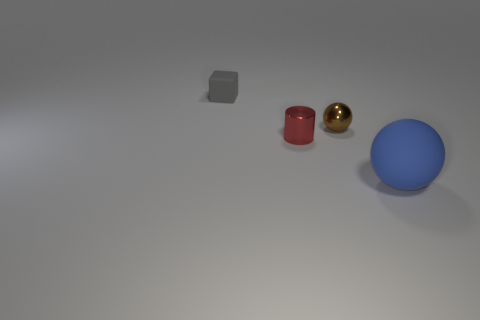What number of gray objects are the same shape as the small brown object? In the image provided, there are no gray objects that share the same shape as the small brown object, which appears to be a cylinder. The only gray object present is a cube, therefore the accurate number of gray objects matching the shape of the small brown cylinder is zero. 